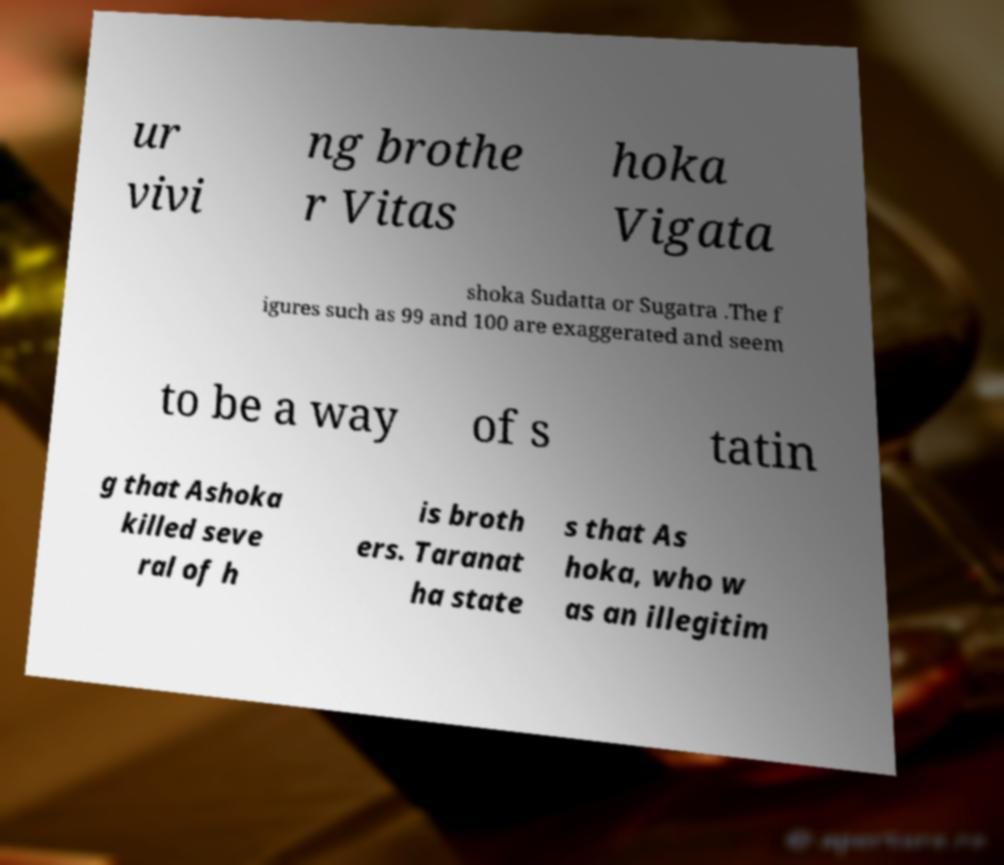Please read and relay the text visible in this image. What does it say? ur vivi ng brothe r Vitas hoka Vigata shoka Sudatta or Sugatra .The f igures such as 99 and 100 are exaggerated and seem to be a way of s tatin g that Ashoka killed seve ral of h is broth ers. Taranat ha state s that As hoka, who w as an illegitim 